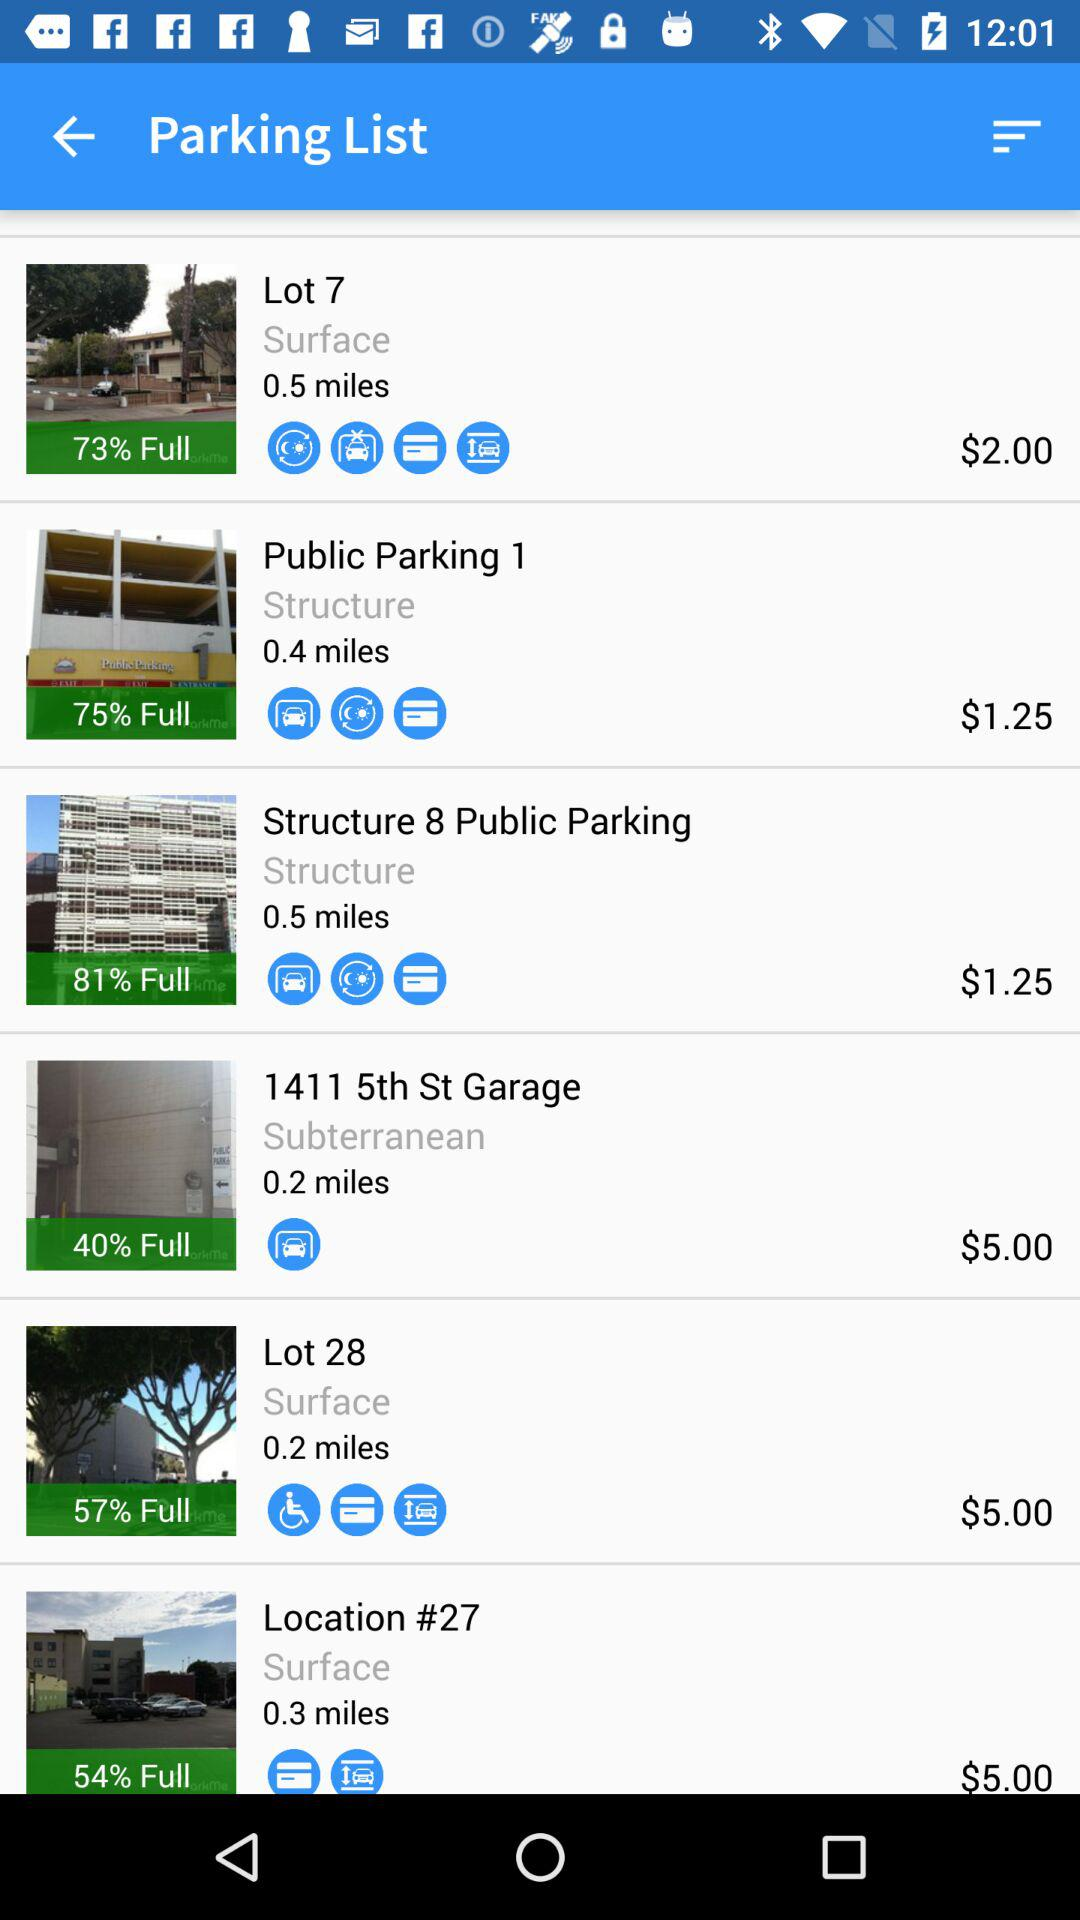Which parking space is 40% full? The parking is 11411 5th St Garage. 